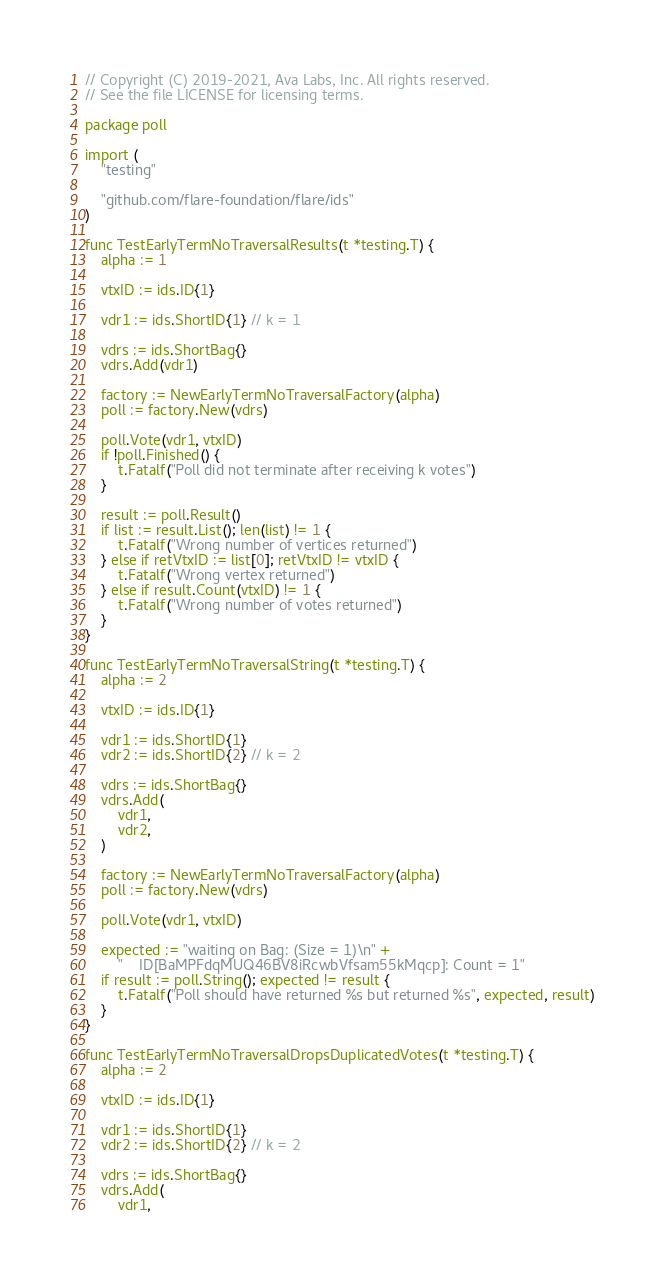<code> <loc_0><loc_0><loc_500><loc_500><_Go_>// Copyright (C) 2019-2021, Ava Labs, Inc. All rights reserved.
// See the file LICENSE for licensing terms.

package poll

import (
	"testing"

	"github.com/flare-foundation/flare/ids"
)

func TestEarlyTermNoTraversalResults(t *testing.T) {
	alpha := 1

	vtxID := ids.ID{1}

	vdr1 := ids.ShortID{1} // k = 1

	vdrs := ids.ShortBag{}
	vdrs.Add(vdr1)

	factory := NewEarlyTermNoTraversalFactory(alpha)
	poll := factory.New(vdrs)

	poll.Vote(vdr1, vtxID)
	if !poll.Finished() {
		t.Fatalf("Poll did not terminate after receiving k votes")
	}

	result := poll.Result()
	if list := result.List(); len(list) != 1 {
		t.Fatalf("Wrong number of vertices returned")
	} else if retVtxID := list[0]; retVtxID != vtxID {
		t.Fatalf("Wrong vertex returned")
	} else if result.Count(vtxID) != 1 {
		t.Fatalf("Wrong number of votes returned")
	}
}

func TestEarlyTermNoTraversalString(t *testing.T) {
	alpha := 2

	vtxID := ids.ID{1}

	vdr1 := ids.ShortID{1}
	vdr2 := ids.ShortID{2} // k = 2

	vdrs := ids.ShortBag{}
	vdrs.Add(
		vdr1,
		vdr2,
	)

	factory := NewEarlyTermNoTraversalFactory(alpha)
	poll := factory.New(vdrs)

	poll.Vote(vdr1, vtxID)

	expected := "waiting on Bag: (Size = 1)\n" +
		"    ID[BaMPFdqMUQ46BV8iRcwbVfsam55kMqcp]: Count = 1"
	if result := poll.String(); expected != result {
		t.Fatalf("Poll should have returned %s but returned %s", expected, result)
	}
}

func TestEarlyTermNoTraversalDropsDuplicatedVotes(t *testing.T) {
	alpha := 2

	vtxID := ids.ID{1}

	vdr1 := ids.ShortID{1}
	vdr2 := ids.ShortID{2} // k = 2

	vdrs := ids.ShortBag{}
	vdrs.Add(
		vdr1,</code> 